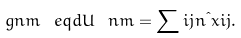Convert formula to latex. <formula><loc_0><loc_0><loc_500><loc_500>\ g n m \ e q d U \ n m = \sum i j n \i x i j .</formula> 